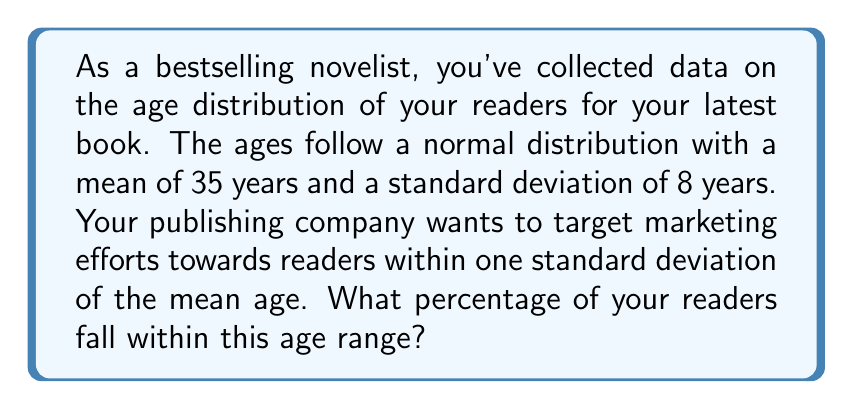Show me your answer to this math problem. To solve this problem, we need to use the properties of the normal distribution and the concept of z-scores.

Step 1: Identify the given information
- The age distribution is normal
- Mean (μ) = 35 years
- Standard deviation (σ) = 8 years
- We need to find the percentage of readers within 1 standard deviation of the mean

Step 2: Calculate the z-scores for the upper and lower bounds
Lower bound: z = (x - μ) / σ = (35 - 8 - 35) / 8 = -1
Upper bound: z = (x - μ) / σ = (35 + 8 - 35) / 8 = 1

Step 3: Use the empirical rule (68-95-99.7 rule)
For a normal distribution:
- Approximately 68% of the data falls within 1 standard deviation of the mean
- Approximately 95% of the data falls within 2 standard deviations of the mean
- Approximately 99.7% of the data falls within 3 standard deviations of the mean

In this case, we're looking at the range within 1 standard deviation, which corresponds to 68% of the data.

Step 4: Verify using the standard normal distribution table
We can also verify this result using the standard normal distribution table:
P(-1 < Z < 1) = P(Z < 1) - P(Z < -1)
              = 0.8413 - 0.1587
              = 0.6826 ≈ 0.68 or 68%

Therefore, approximately 68% of your readers fall within one standard deviation of the mean age.
Answer: 68% 